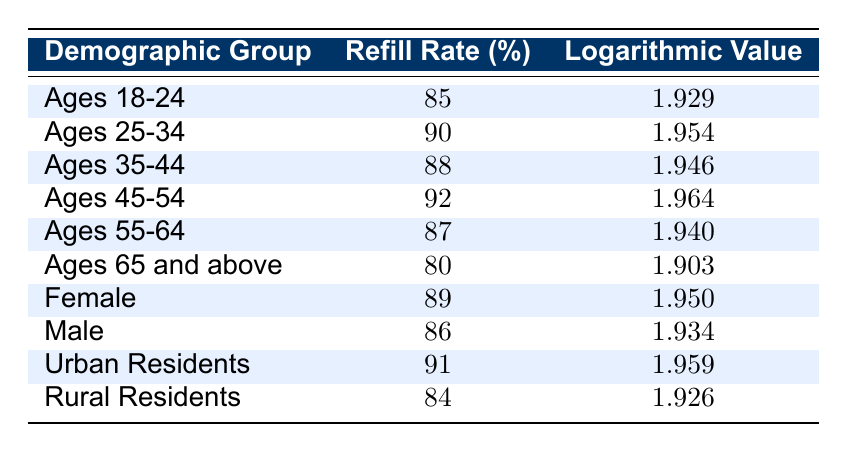What is the refill rate for the demographic group "Ages 45-54"? Referring to the table, under the "Ages 45-54" demographic group, the refill rate is listed as 92%.
Answer: 92% What is the logarithmic value for the demographic group "Rural Residents"? According to the table, the "Rural Residents" demographic group has a logarithmic value of 1.926.
Answer: 1.926 What is the difference between the refill rates of "Ages 25-34" and "Ages 65 and above"? From the table, the refill rate for "Ages 25-34" is 90% and for "Ages 65 and above" is 80%. The difference is 90 - 80 = 10.
Answer: 10% What is the average refill rate for "Urban Residents" and "Female" demographic groups? The refill rate for "Urban Residents" is 91% and for "Female" is 89%. The average is calculated as (91 + 89) / 2 = 90.
Answer: 90 Is the refill rate higher for males or rural residents? The refill rate for males is 86% and for rural residents is 84%. Since 86% is greater than 84%, the refill rate is higher for males.
Answer: Yes What is the highest refill rate among all demographic groups listed? Looking through all the data points, the highest refill rate is 92% found in the "Ages 45-54" demographic group.
Answer: 92% Which demographic group has the lowest logarithmic value? By checking the logarithmic values, "Ages 65 and above" has the lowest value at 1.903.
Answer: Ages 65 and above What is the refill rate for females compared to ages 55-64? The refill rate for females is 89% while for ages 55-64 it is 87%. 89% is greater than 87%, indicating females have a higher refill rate.
Answer: Females have a higher refill rate What is the sum of the refill rates for "Ages 18-24" and "Ages 35-44"? The refill rate for "Ages 18-24" is 85% and for "Ages 35-44" is 88%. Summing these gives 85 + 88 = 173.
Answer: 173 